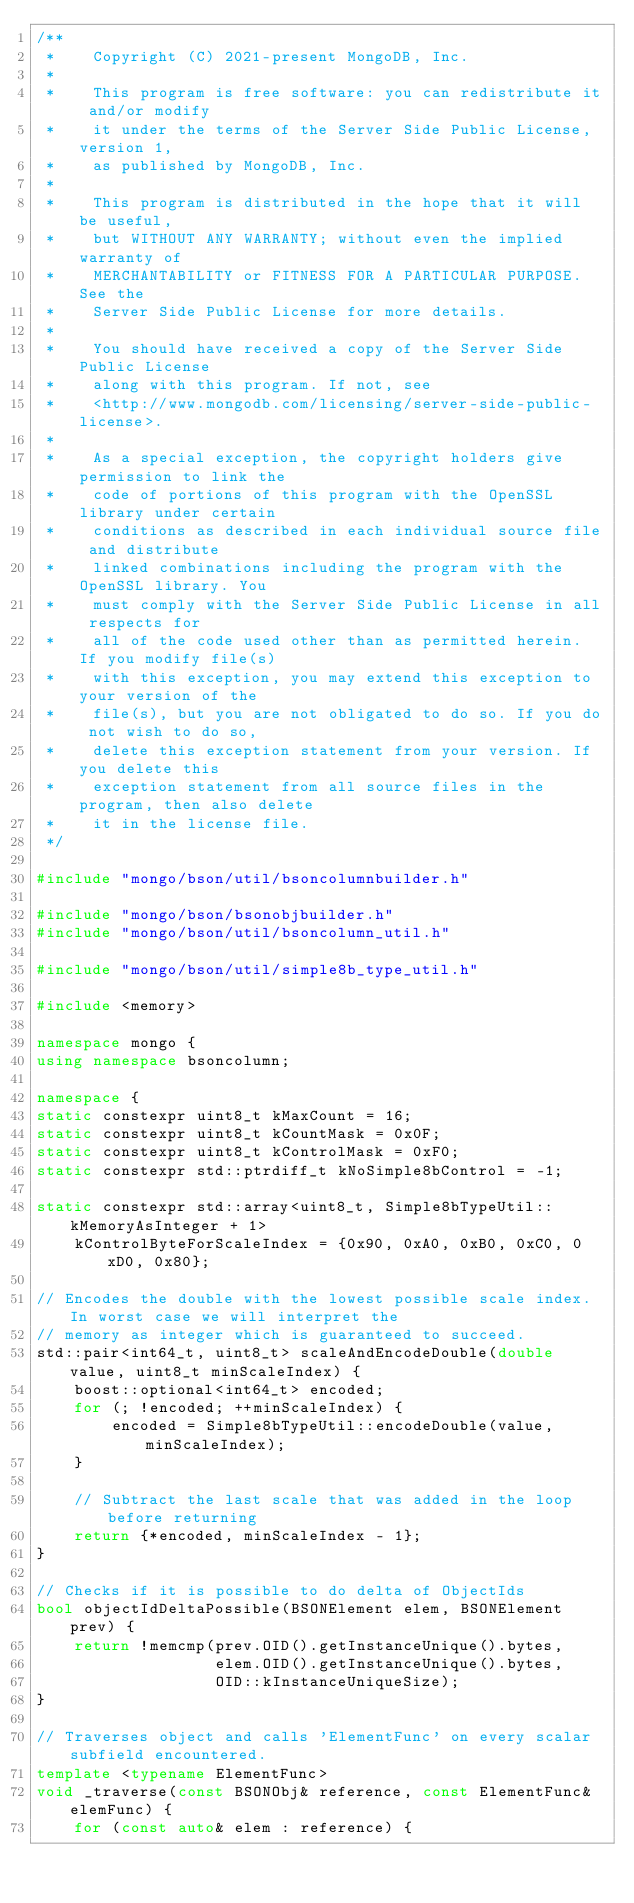<code> <loc_0><loc_0><loc_500><loc_500><_C++_>/**
 *    Copyright (C) 2021-present MongoDB, Inc.
 *
 *    This program is free software: you can redistribute it and/or modify
 *    it under the terms of the Server Side Public License, version 1,
 *    as published by MongoDB, Inc.
 *
 *    This program is distributed in the hope that it will be useful,
 *    but WITHOUT ANY WARRANTY; without even the implied warranty of
 *    MERCHANTABILITY or FITNESS FOR A PARTICULAR PURPOSE.  See the
 *    Server Side Public License for more details.
 *
 *    You should have received a copy of the Server Side Public License
 *    along with this program. If not, see
 *    <http://www.mongodb.com/licensing/server-side-public-license>.
 *
 *    As a special exception, the copyright holders give permission to link the
 *    code of portions of this program with the OpenSSL library under certain
 *    conditions as described in each individual source file and distribute
 *    linked combinations including the program with the OpenSSL library. You
 *    must comply with the Server Side Public License in all respects for
 *    all of the code used other than as permitted herein. If you modify file(s)
 *    with this exception, you may extend this exception to your version of the
 *    file(s), but you are not obligated to do so. If you do not wish to do so,
 *    delete this exception statement from your version. If you delete this
 *    exception statement from all source files in the program, then also delete
 *    it in the license file.
 */

#include "mongo/bson/util/bsoncolumnbuilder.h"

#include "mongo/bson/bsonobjbuilder.h"
#include "mongo/bson/util/bsoncolumn_util.h"

#include "mongo/bson/util/simple8b_type_util.h"

#include <memory>

namespace mongo {
using namespace bsoncolumn;

namespace {
static constexpr uint8_t kMaxCount = 16;
static constexpr uint8_t kCountMask = 0x0F;
static constexpr uint8_t kControlMask = 0xF0;
static constexpr std::ptrdiff_t kNoSimple8bControl = -1;

static constexpr std::array<uint8_t, Simple8bTypeUtil::kMemoryAsInteger + 1>
    kControlByteForScaleIndex = {0x90, 0xA0, 0xB0, 0xC0, 0xD0, 0x80};

// Encodes the double with the lowest possible scale index. In worst case we will interpret the
// memory as integer which is guaranteed to succeed.
std::pair<int64_t, uint8_t> scaleAndEncodeDouble(double value, uint8_t minScaleIndex) {
    boost::optional<int64_t> encoded;
    for (; !encoded; ++minScaleIndex) {
        encoded = Simple8bTypeUtil::encodeDouble(value, minScaleIndex);
    }

    // Subtract the last scale that was added in the loop before returning
    return {*encoded, minScaleIndex - 1};
}

// Checks if it is possible to do delta of ObjectIds
bool objectIdDeltaPossible(BSONElement elem, BSONElement prev) {
    return !memcmp(prev.OID().getInstanceUnique().bytes,
                   elem.OID().getInstanceUnique().bytes,
                   OID::kInstanceUniqueSize);
}

// Traverses object and calls 'ElementFunc' on every scalar subfield encountered.
template <typename ElementFunc>
void _traverse(const BSONObj& reference, const ElementFunc& elemFunc) {
    for (const auto& elem : reference) {</code> 